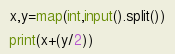Convert code to text. <code><loc_0><loc_0><loc_500><loc_500><_Python_>x,y=map(int,input().split())

print(x+(y/2))
</code> 